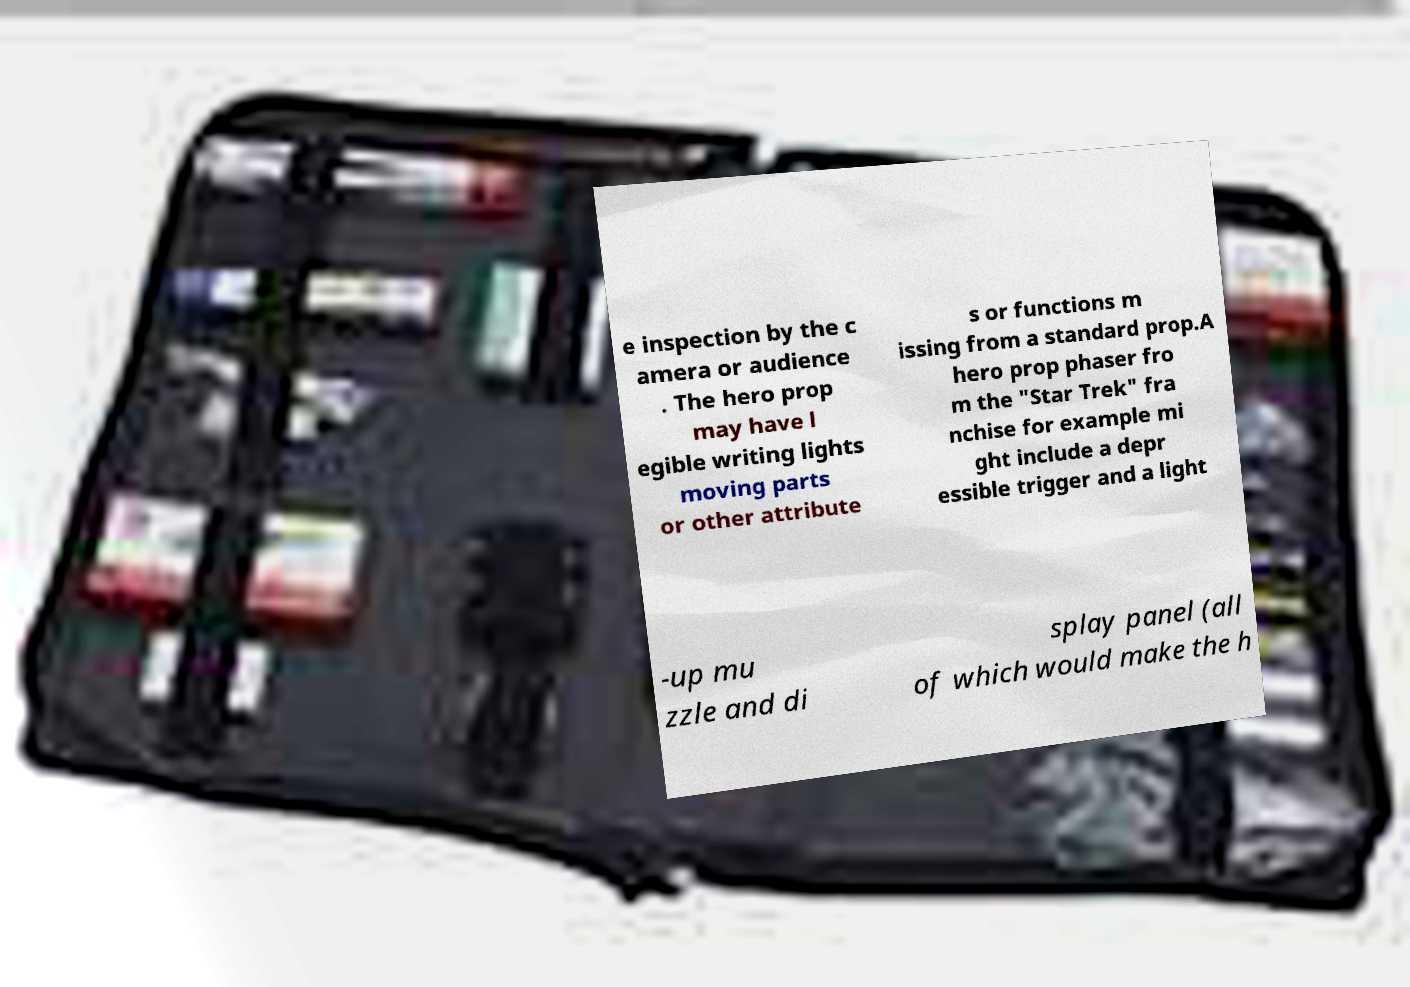Can you read and provide the text displayed in the image?This photo seems to have some interesting text. Can you extract and type it out for me? e inspection by the c amera or audience . The hero prop may have l egible writing lights moving parts or other attribute s or functions m issing from a standard prop.A hero prop phaser fro m the "Star Trek" fra nchise for example mi ght include a depr essible trigger and a light -up mu zzle and di splay panel (all of which would make the h 